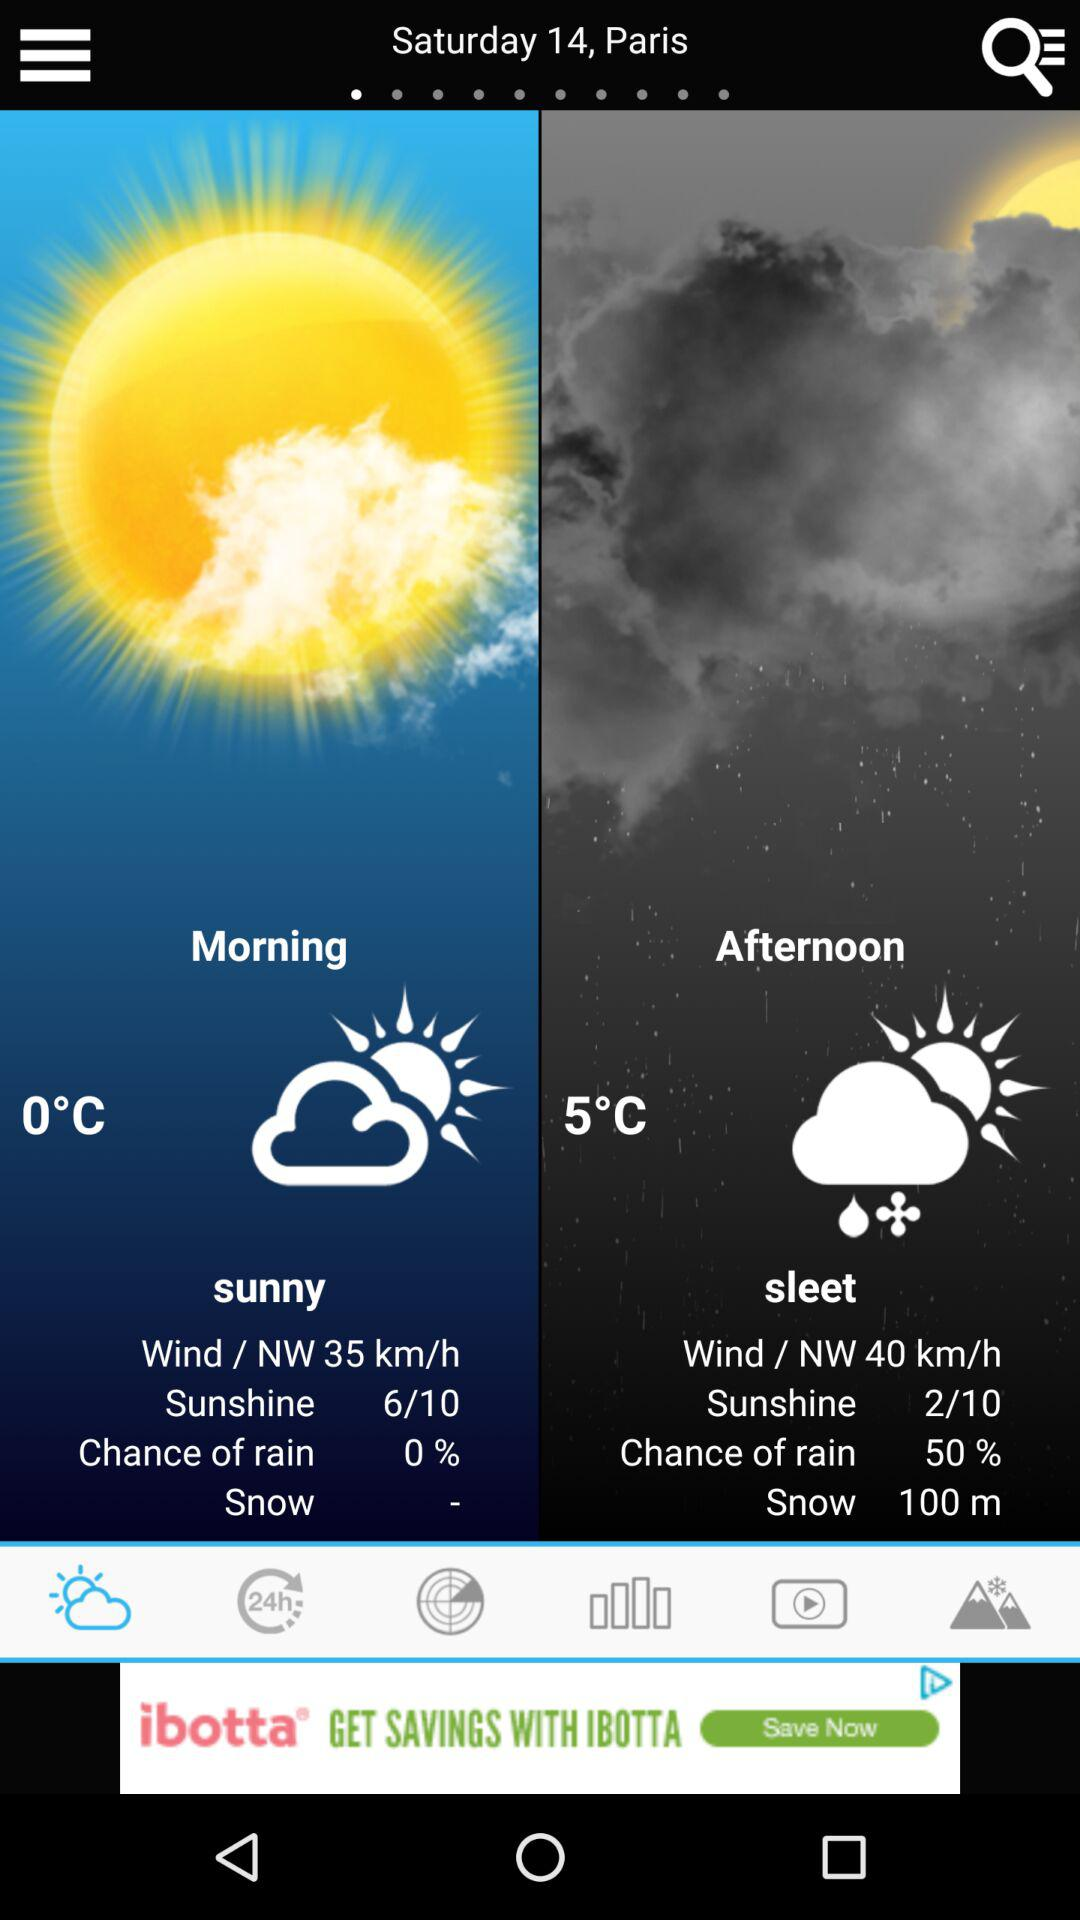What is the location? The location is Paris. 